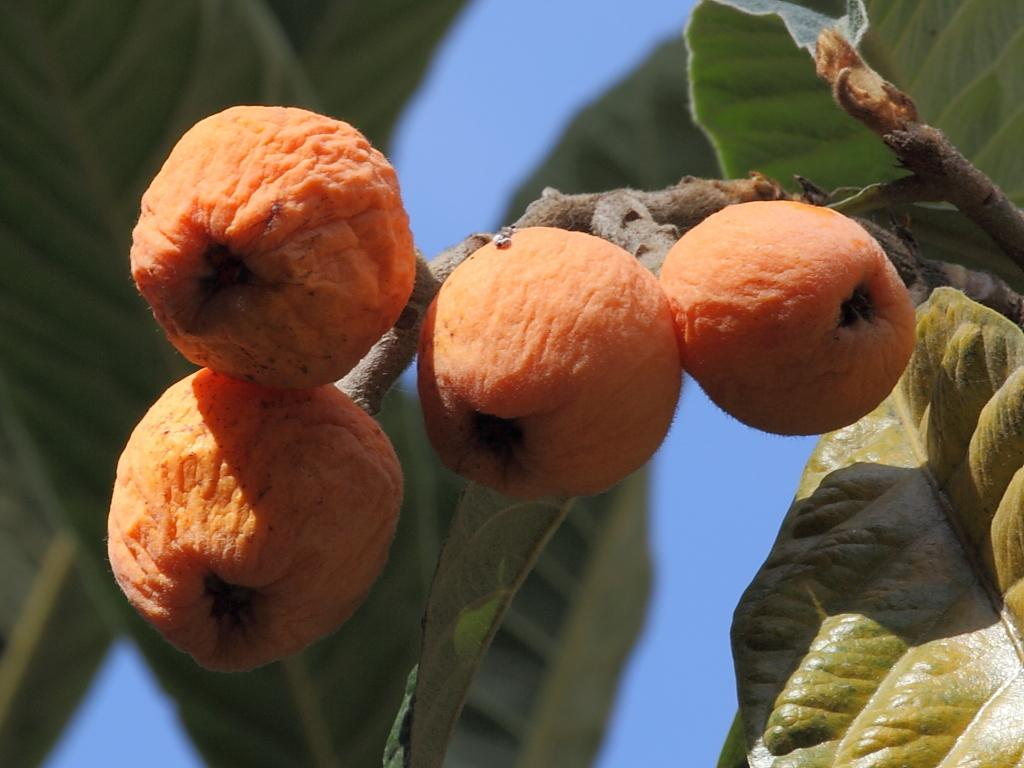What is the main subject of the image? The main subject of the image is a stem with fruits. What else can be seen in the image besides the stem with fruits? There are leaves in the image. Where is the goat in the image? There is no goat present in the image. What type of brush is being used to paint the fruits in the image? There is no brush or painting activity depicted in the image; it simply shows a stem with fruits and leaves. 